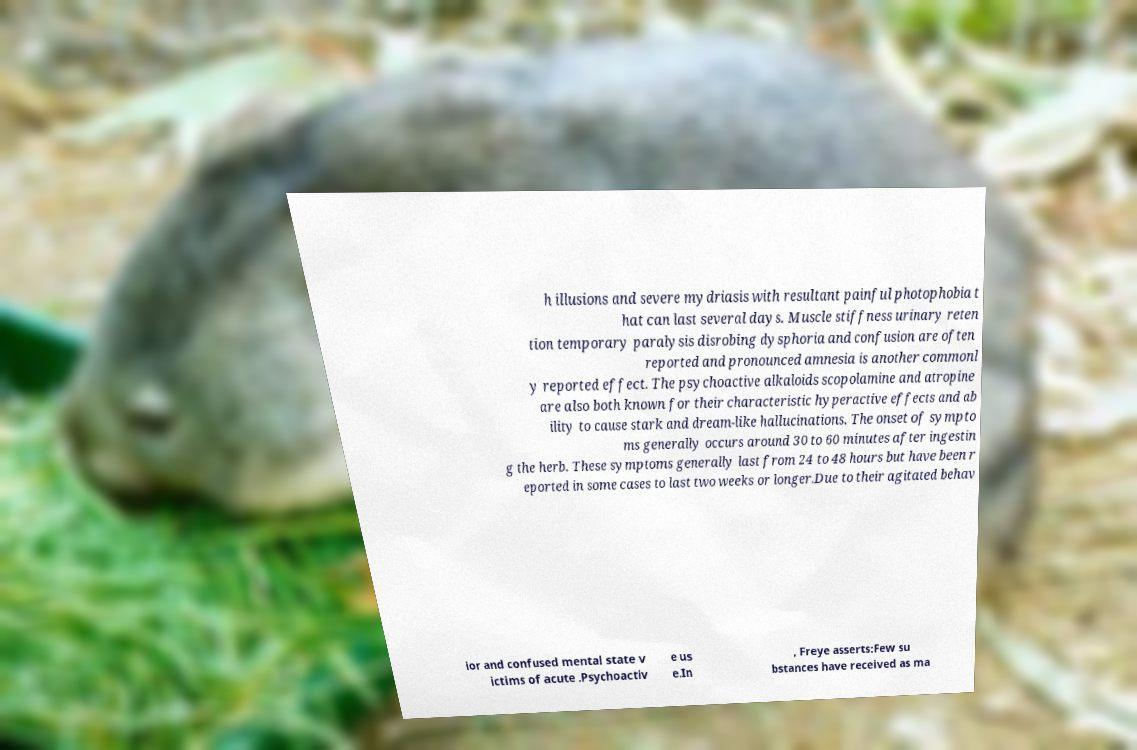Can you accurately transcribe the text from the provided image for me? h illusions and severe mydriasis with resultant painful photophobia t hat can last several days. Muscle stiffness urinary reten tion temporary paralysis disrobing dysphoria and confusion are often reported and pronounced amnesia is another commonl y reported effect. The psychoactive alkaloids scopolamine and atropine are also both known for their characteristic hyperactive effects and ab ility to cause stark and dream-like hallucinations. The onset of sympto ms generally occurs around 30 to 60 minutes after ingestin g the herb. These symptoms generally last from 24 to 48 hours but have been r eported in some cases to last two weeks or longer.Due to their agitated behav ior and confused mental state v ictims of acute .Psychoactiv e us e.In , Freye asserts:Few su bstances have received as ma 